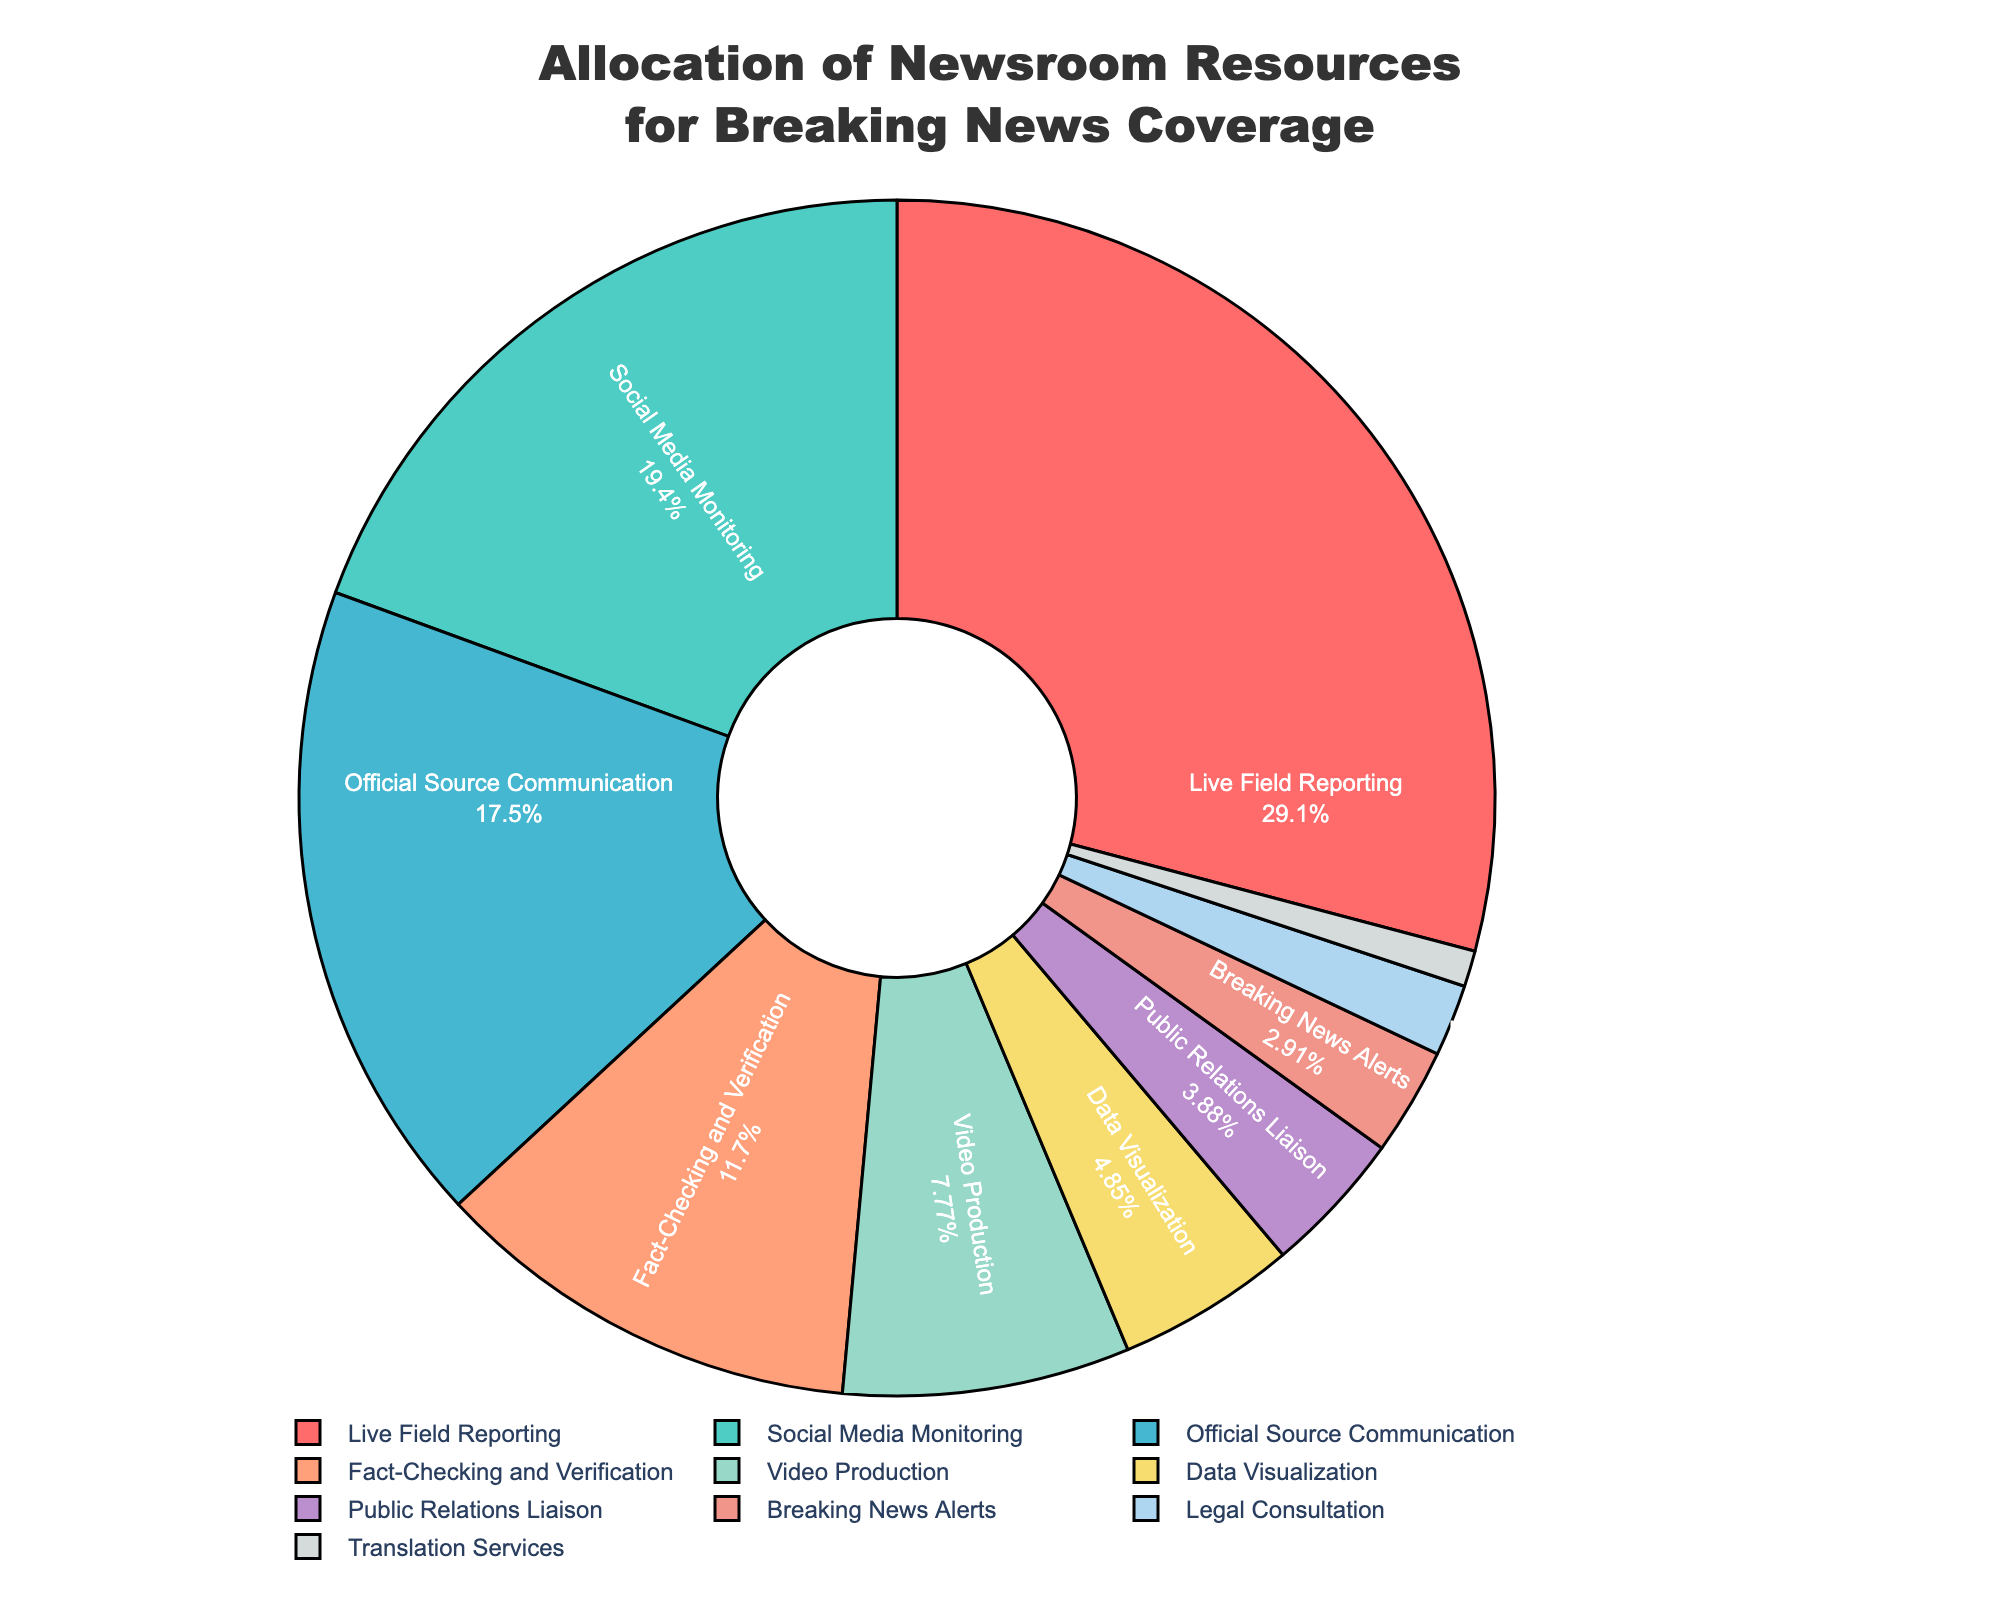What category receives the highest allocation of newsroom resources for breaking news coverage? The category with the largest percentage slice in the pie chart is the one that receives the highest allocation. In this case, it is "Live Field Reporting".
Answer: Live Field Reporting How much more percentage is allocated to Social Media Monitoring compared to Public Relations Liaison? Social Media Monitoring is 20% and Public Relations Liaison is 4%. The difference is 20% - 4% = 16%.
Answer: 16% Which two categories together make up a quarter (25%) of the total resource allocation? Fact-Checking and Verification (12%) and Video Production (8%) together make 12% + 8% = 20%. Adding Data Visualization (5%) reaches slightly over 25%. The correct pair adding up to exactly 25% consists of Fact-Checking and Verification (12%) and Breaking News Alerts (3%). This isn't possible with provided options.
Answer: Not possible What percentage is the combined allocation for Fact-Checking and Verification, Translation Services, and Legal Consultation? Add the percentages of Fact-Checking and Verification (12%), Translation Services (1%), and Legal Consultation (2%). The total is 12% + 1% + 2% = 15%.
Answer: 15% Which category has the smallest allocation of newsroom resources? The smallest slice in the pie chart represents the category with the smallest allocation, which is "Translation Services" at 1%.
Answer: Translation Services How does the allocation for Data Visualization compare to Video Production? Data Visualization is allocated 5%, whereas Video Production is allocated 8%. Hence, Video Production has a higher allocation by 3%.
Answer: Video Production has 3% more What is the total percentage allocated to categories related to communication with others external to the newsroom? (e.g., Official Source Communication, Public Relations Liaison, Legal Consultation) Add the percentages for Official Source Communication (18%), Public Relations Liaison (4%), and Legal Consultation (2%). The total is 18% + 4% + 2% = 24%.
Answer: 24% What percentage of the resources is allocated to both Breaking News Alerts and Translation Services together? Breaking News Alerts is 3% and Translation Services is 1%. The combined total is 3% + 1% = 4%.
Answer: 4% Which category has approximately half the allocation of Social Media Monitoring? Social Media Monitoring is allotted 20%, and approximately half of that is 10%. Looking at the categories, Fact-Checking and Verification is closest at 12%.
Answer: Fact-Checking and Verification 